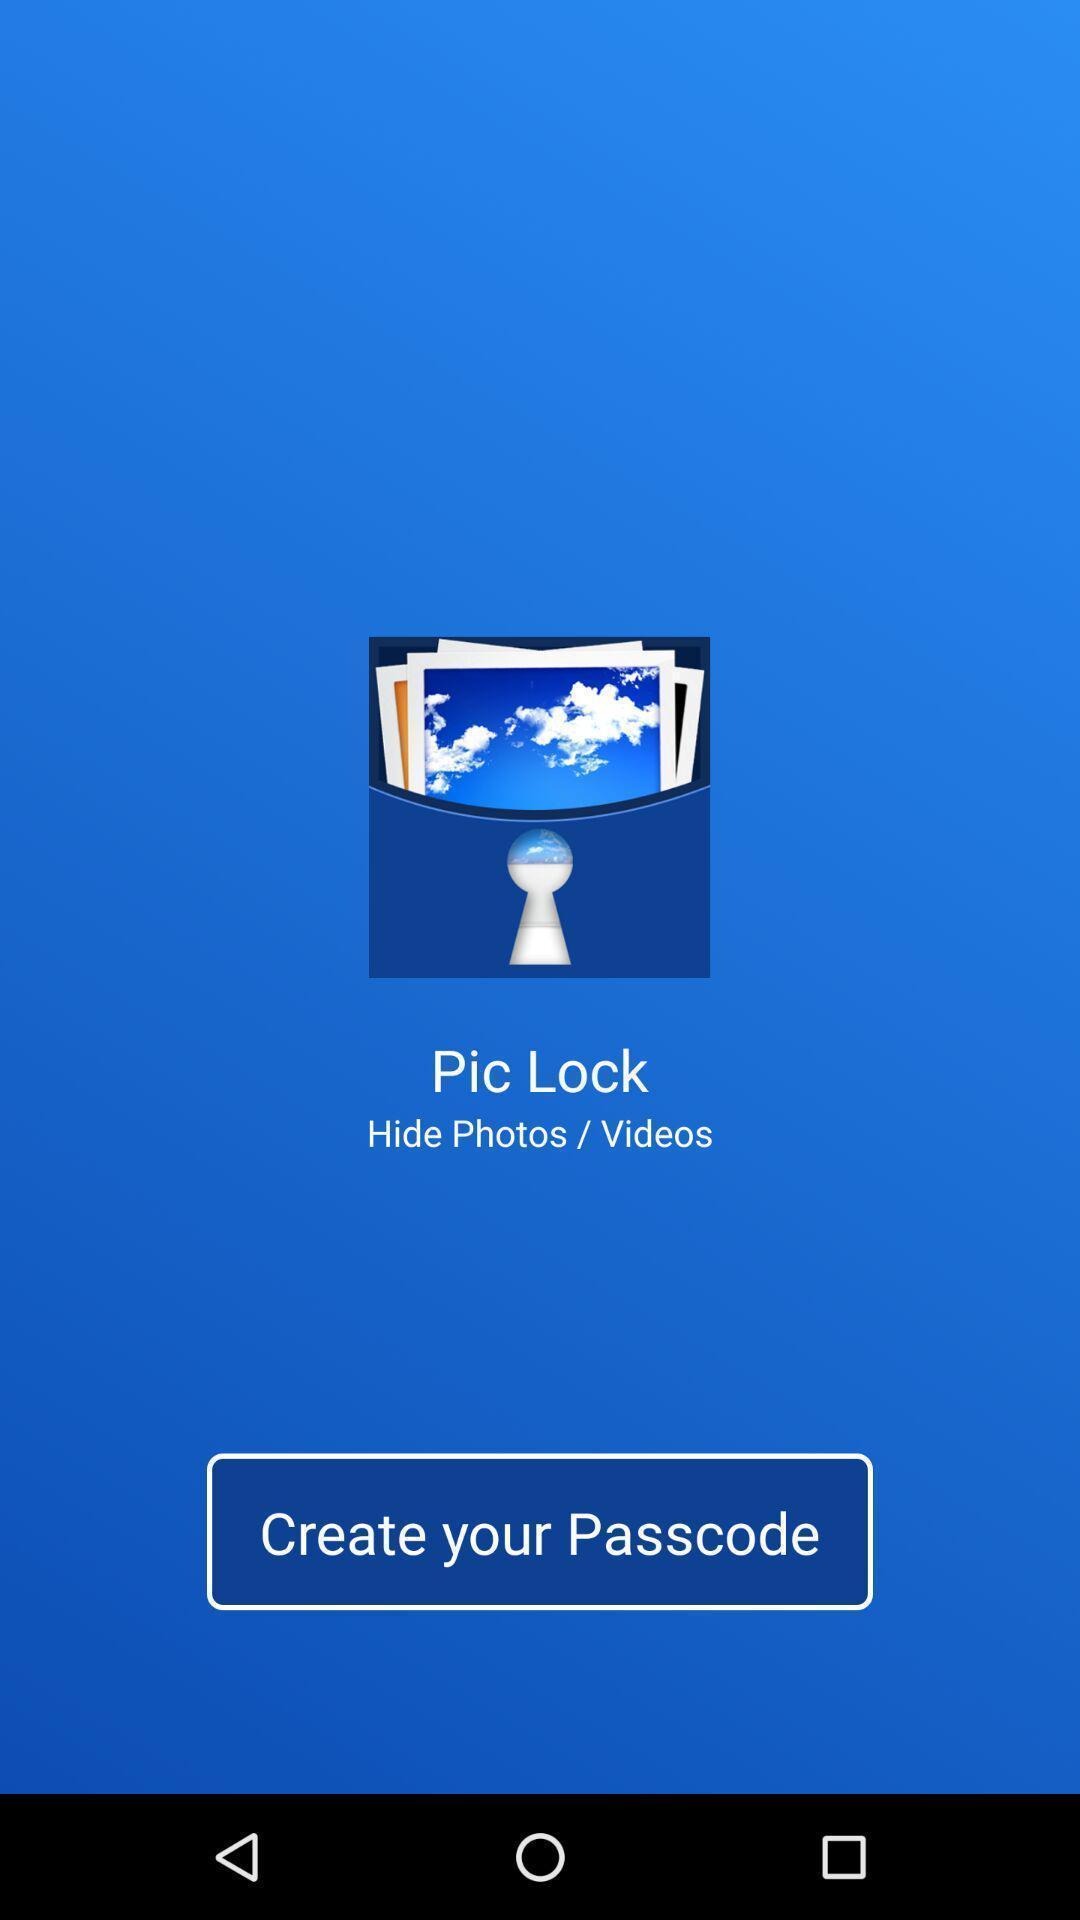Summarize the main components in this picture. Screen shows create passcode for an app. 